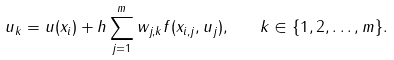Convert formula to latex. <formula><loc_0><loc_0><loc_500><loc_500>u _ { k } = u ( x _ { i } ) + h \sum _ { j = 1 } ^ { m } w _ { j , k } f ( x _ { i , j } , u _ { j } ) , \quad k \in \{ 1 , 2 , \dots , m \} .</formula> 